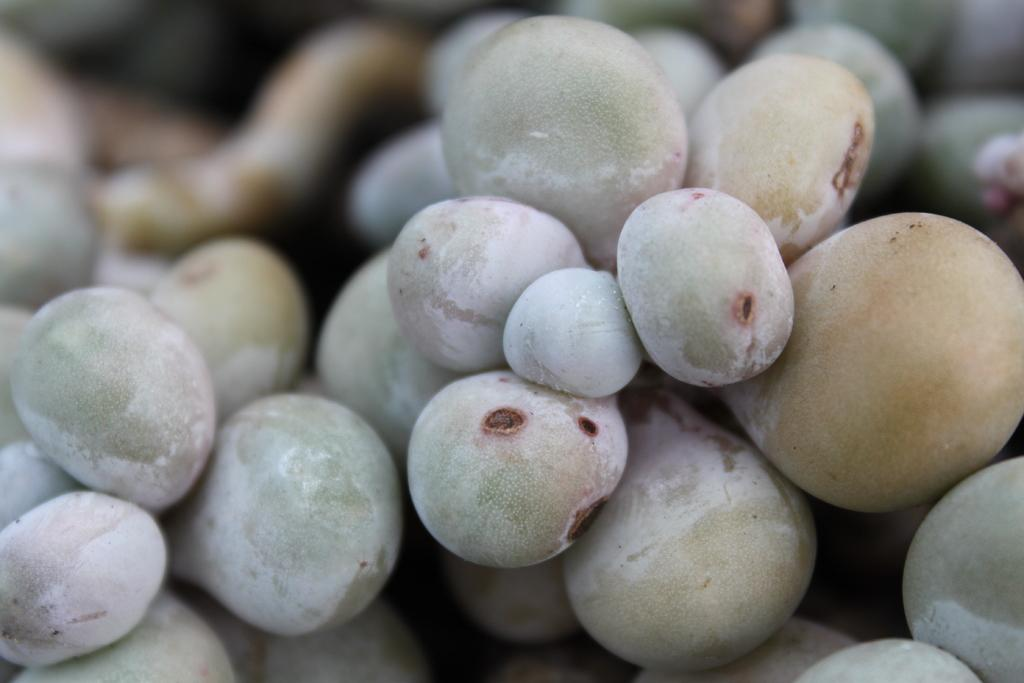What type of food can be seen in the image? There are fruits in the image. Can you describe the colors of the fruits? The fruits are in cream, white, and lite green colors. What is the appearance of the background in the image? The background of the image is blurred. What type of pancake is being served in the image? There is no pancake present in the image; it features fruits in cream, white, and lite green colors. Can you see a kitten playing with the fruits in the image? There is no kitten present in the image; it only features fruits in a bowl. 